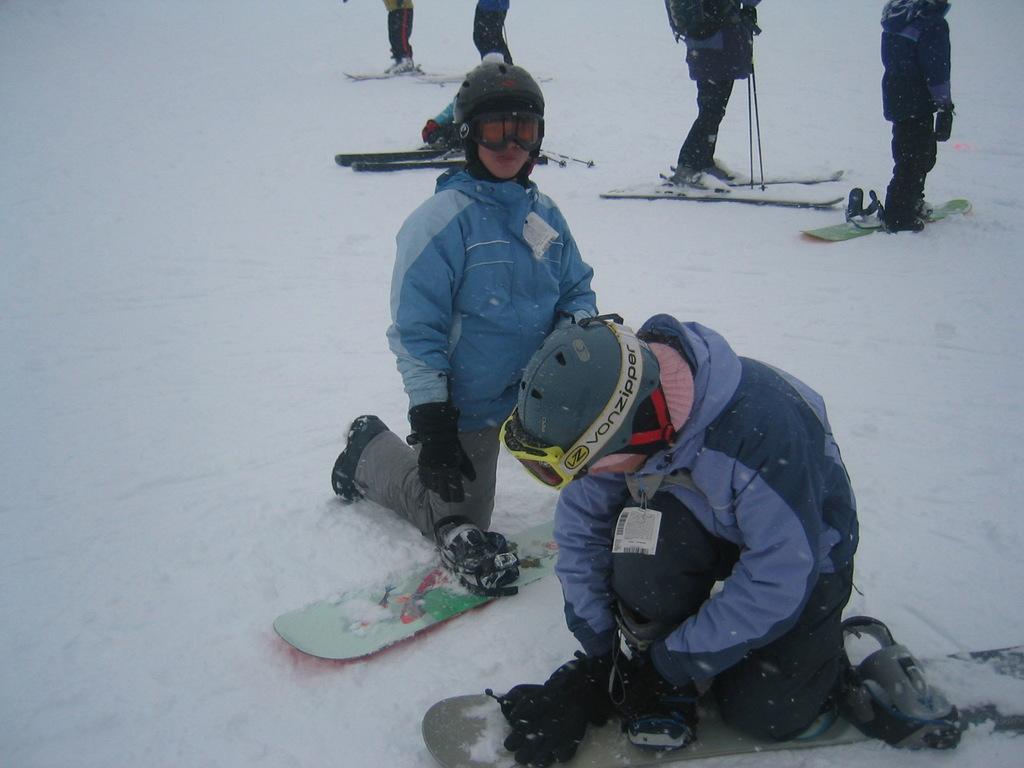Please provide a concise description of this image. In this picture we can see some persons. These are the ski boards and this is snow. 